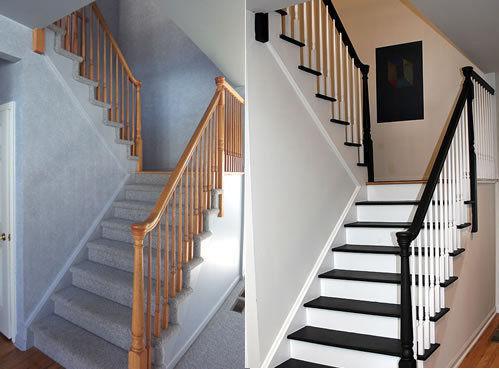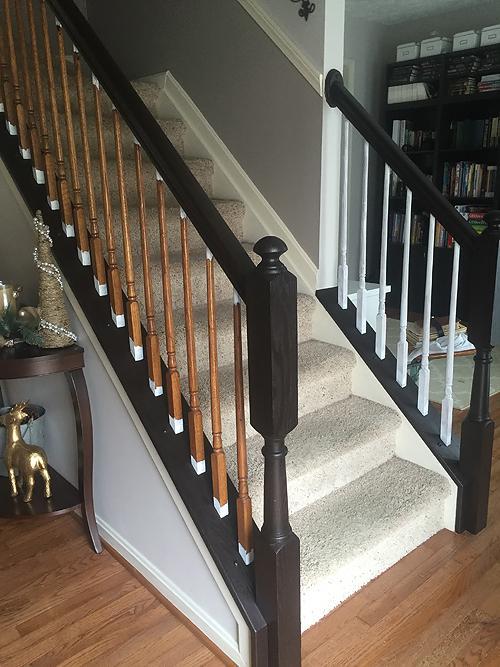The first image is the image on the left, the second image is the image on the right. Evaluate the accuracy of this statement regarding the images: "There are at least two l-shaped staircases.". Is it true? Answer yes or no. Yes. 